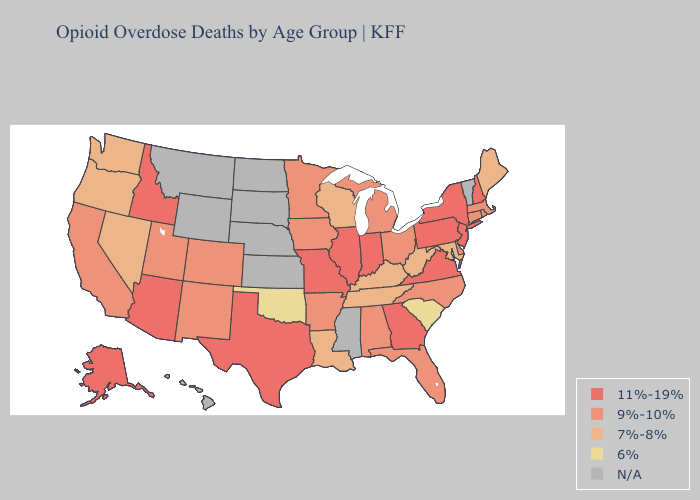What is the lowest value in the USA?
Write a very short answer. 6%. Does Massachusetts have the highest value in the Northeast?
Be succinct. No. What is the lowest value in the West?
Concise answer only. 7%-8%. Does Wisconsin have the lowest value in the MidWest?
Be succinct. Yes. What is the value of Oklahoma?
Give a very brief answer. 6%. Name the states that have a value in the range 9%-10%?
Give a very brief answer. Alabama, Arkansas, California, Colorado, Connecticut, Delaware, Florida, Iowa, Massachusetts, Michigan, Minnesota, New Mexico, North Carolina, Ohio, Rhode Island, Utah. What is the value of Virginia?
Give a very brief answer. 11%-19%. Name the states that have a value in the range 7%-8%?
Give a very brief answer. Kentucky, Louisiana, Maine, Maryland, Nevada, Oregon, Tennessee, Washington, West Virginia, Wisconsin. What is the highest value in the MidWest ?
Answer briefly. 11%-19%. What is the highest value in the MidWest ?
Keep it brief. 11%-19%. Does Rhode Island have the highest value in the Northeast?
Quick response, please. No. Among the states that border North Dakota , which have the highest value?
Short answer required. Minnesota. How many symbols are there in the legend?
Short answer required. 5. What is the lowest value in the USA?
Short answer required. 6%. 